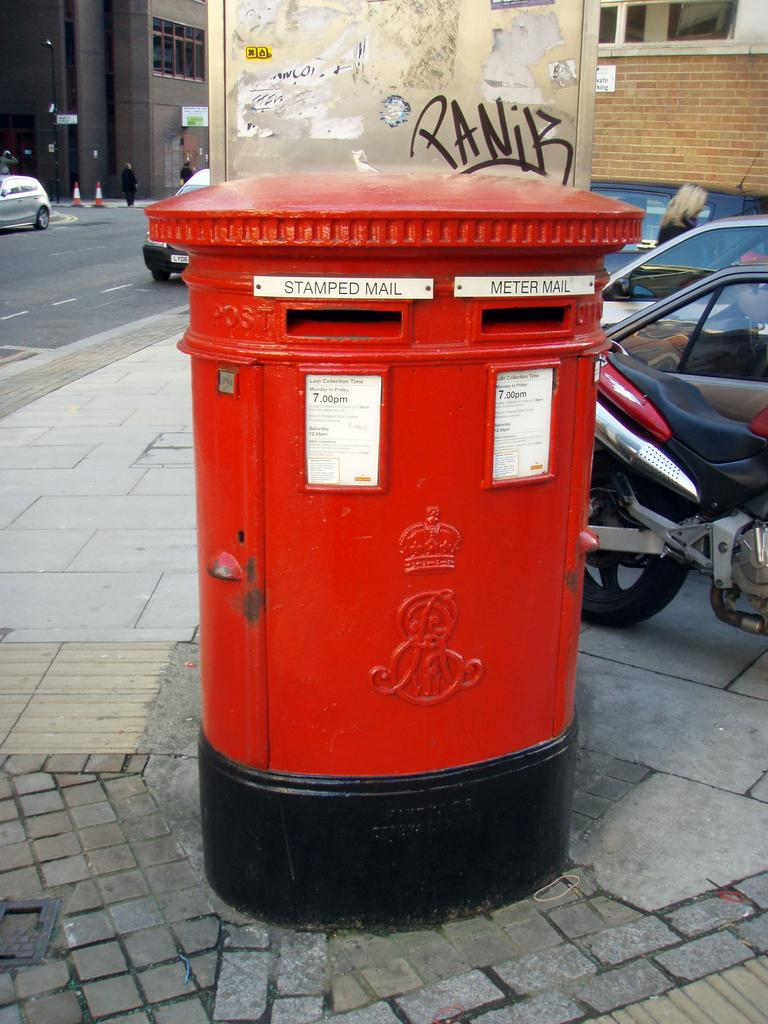What object is the main focus of the image? There is a post box in the image. What else can be seen in the image besides the post box? There are vehicles, four persons standing, cone barricades, buildings, and boards visible in the image. Can you describe the vehicles in the image? The provided facts do not specify the type or characteristics of the vehicles. What might the boards be used for in the image? The purpose of the boards in the image cannot be determined from the provided facts. What type of throat-soothing remedy is being prepared in the oven in the image? There is no oven or throat-soothing remedy present in the image. What type of prose is being written on the boards in the image? There is no writing or prose visible on the boards in the image. 